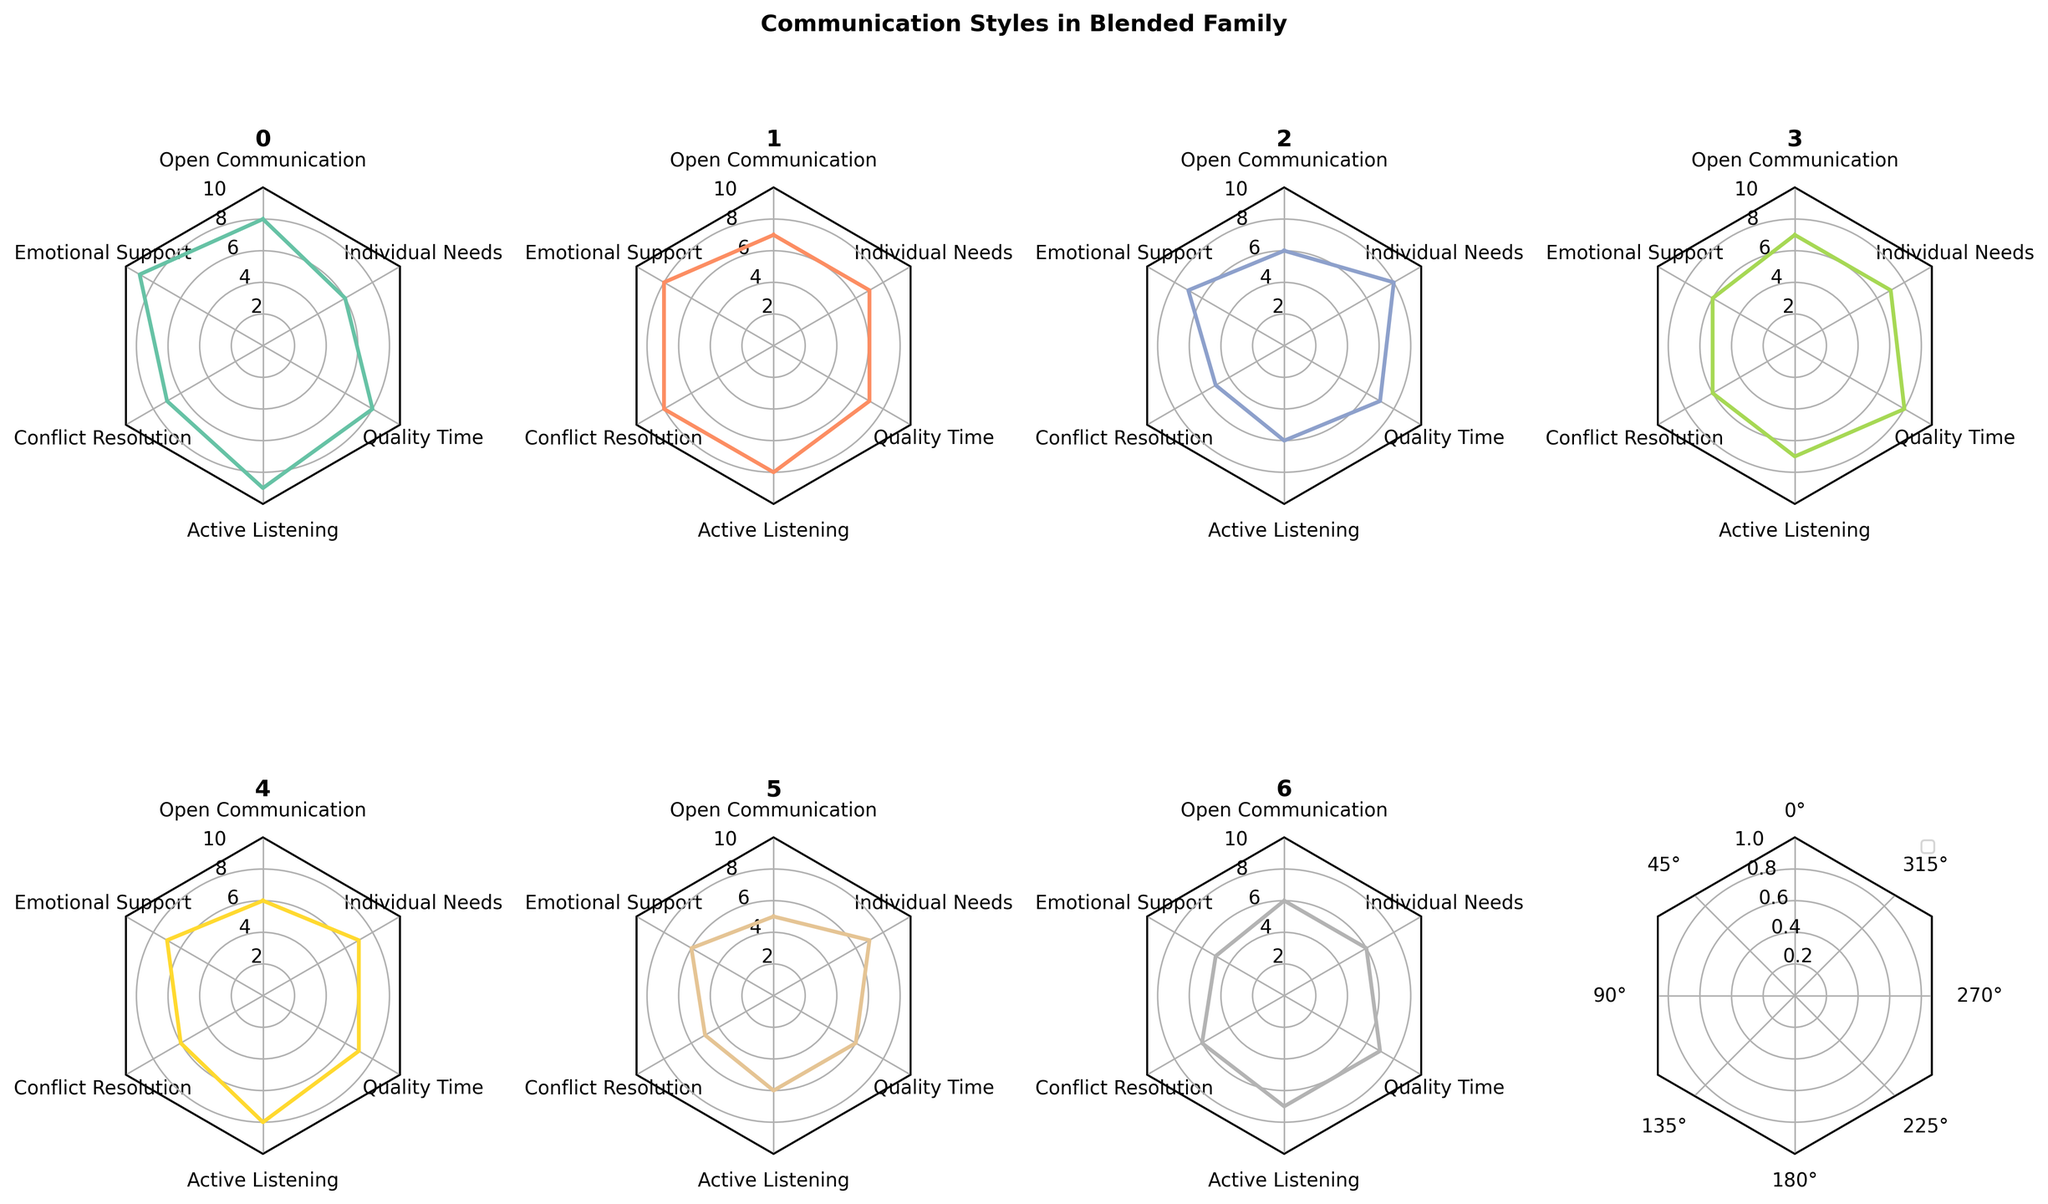What is the title of the figure? The title is found at the top center of the figure where it is clearly labeled. It sets the context for the entire plot.
Answer: Communication Styles in Blended Family Which family member scores the highest in Emotional Support? By looking at the Emotional Support axis, noted by the highest score among all family members is clearly marked on the radar plot for each individual.
Answer: Mother How many family members score 7 or higher in Active Listening? Check the Active Listening axis and count the number of family members whose values reach 7 or higher.
Answer: 5 Which family member has the lowest score in Open Communication? Open Communication scores can be found on their respective axis; identify and compare scores.
Answer: Step-Child1 What’s the average score for Quality Time across all family members? Sum the Quality Time scores for all family members (8 + 7 + 7 + 8 + 7 + 6 + 7) and divide by the number of family members (7).
Answer: 7 Who scores equally in Conflict Resolution and Individual Needs? Compare the Conflict Resolution and Individual Needs scores for each family member and identify if they match.
Answer: Father Which family members have matching scores in Open Communication? Compare the Open Communication scores for any matches among the family members.
Answer: Child2, Step-Parent Who has the most balanced scores across the six categories? Evaluate each radar plot for consistency across all axes and minimal deviations. This indicates the most balanced scores.
Answer: Father Which family member's scores differ the most between Emotional Support and Active Listening? Subtract each individual's score for Active Listening from Emotional Support and identify the largest difference.
Answer: Child1 Compare the scores of Child2 and Step-Parent in Active Listening. Who scores higher? Check the Active Listening scores of Child2 and Step-Parent, compare them.
Answer: Step-Parent 